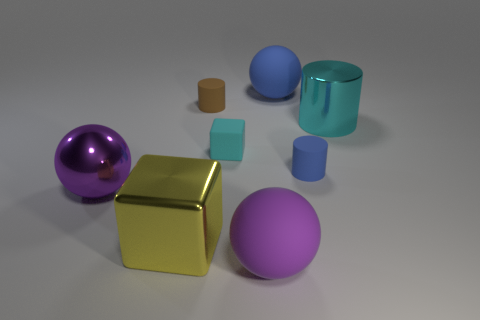Add 1 brown cubes. How many objects exist? 9 Subtract all blue balls. How many balls are left? 2 Subtract all big purple metallic spheres. How many spheres are left? 2 Subtract all cylinders. How many objects are left? 5 Subtract 2 spheres. How many spheres are left? 1 Subtract all green balls. Subtract all green cylinders. How many balls are left? 3 Subtract all red balls. How many cyan cylinders are left? 1 Subtract all red objects. Subtract all large spheres. How many objects are left? 5 Add 8 brown things. How many brown things are left? 9 Add 4 large shiny spheres. How many large shiny spheres exist? 5 